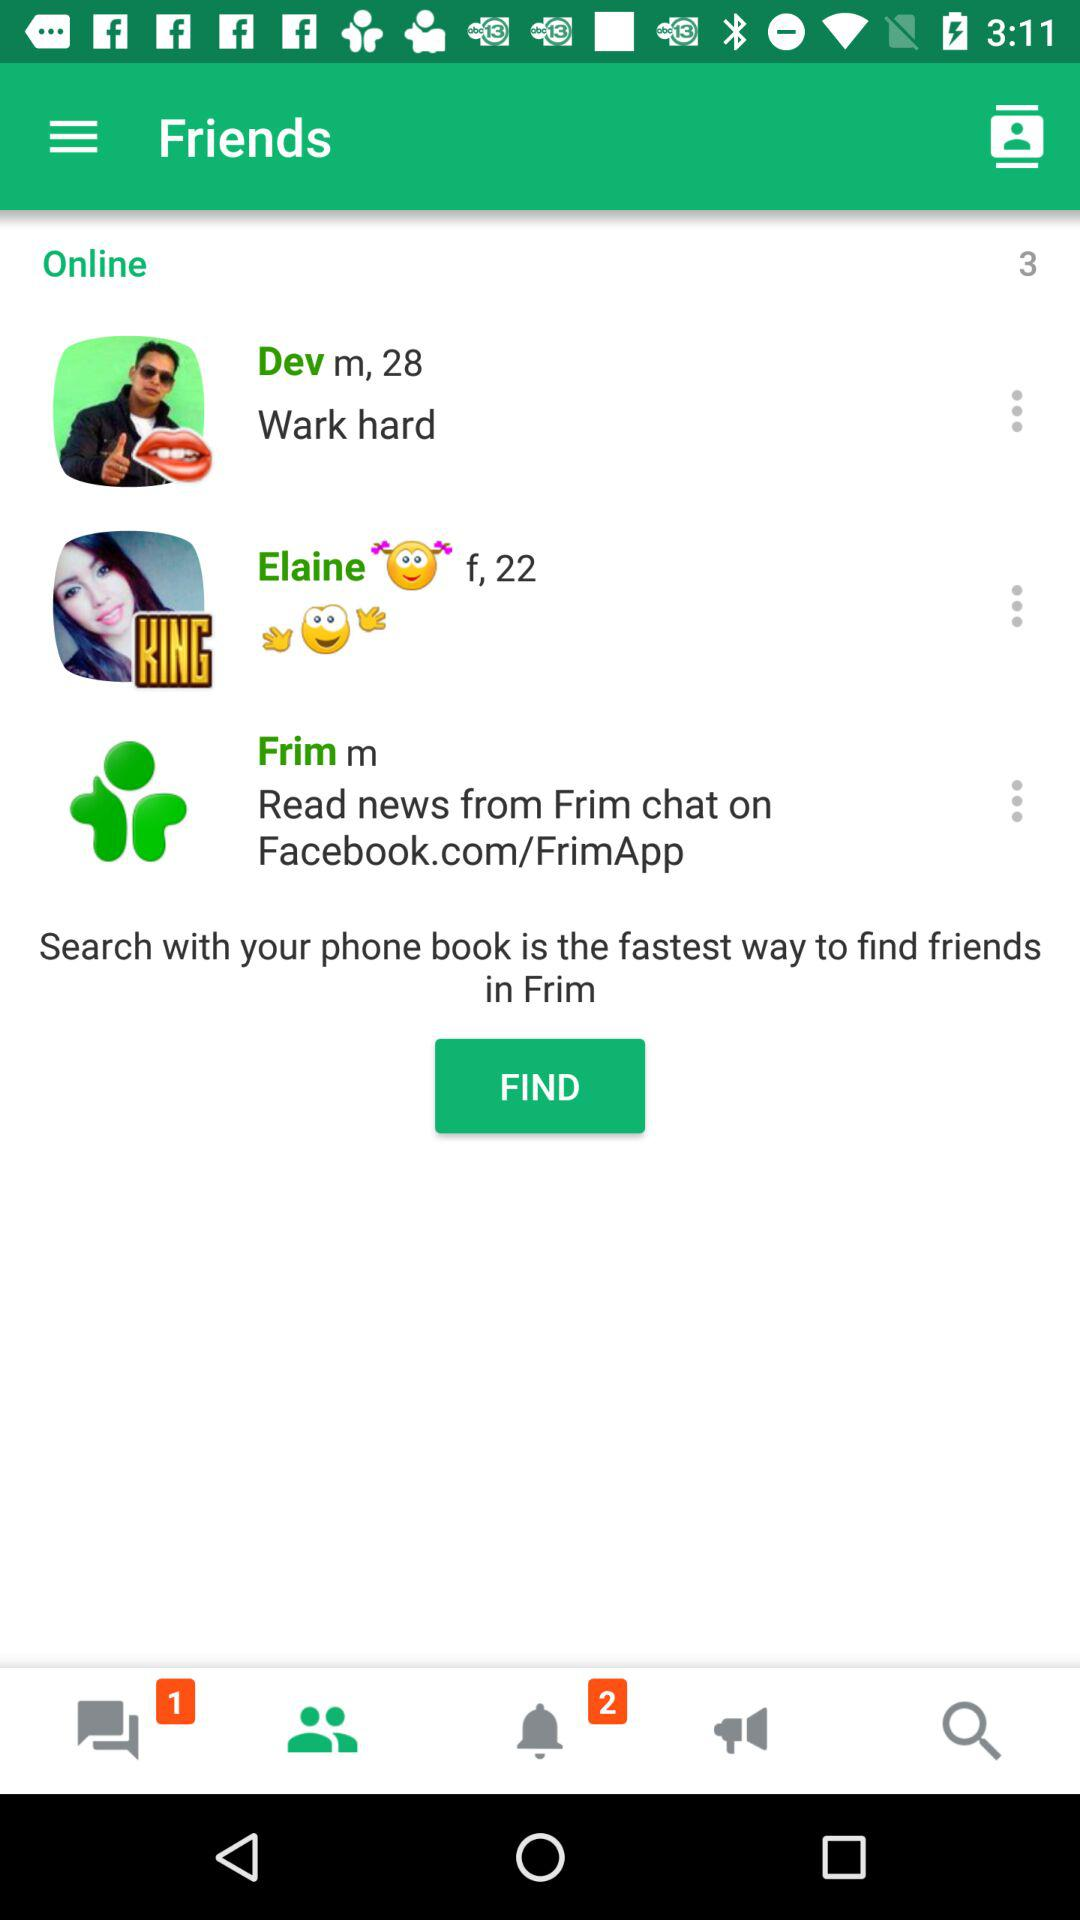What is the age of Dev? Dev is 28 years old. 